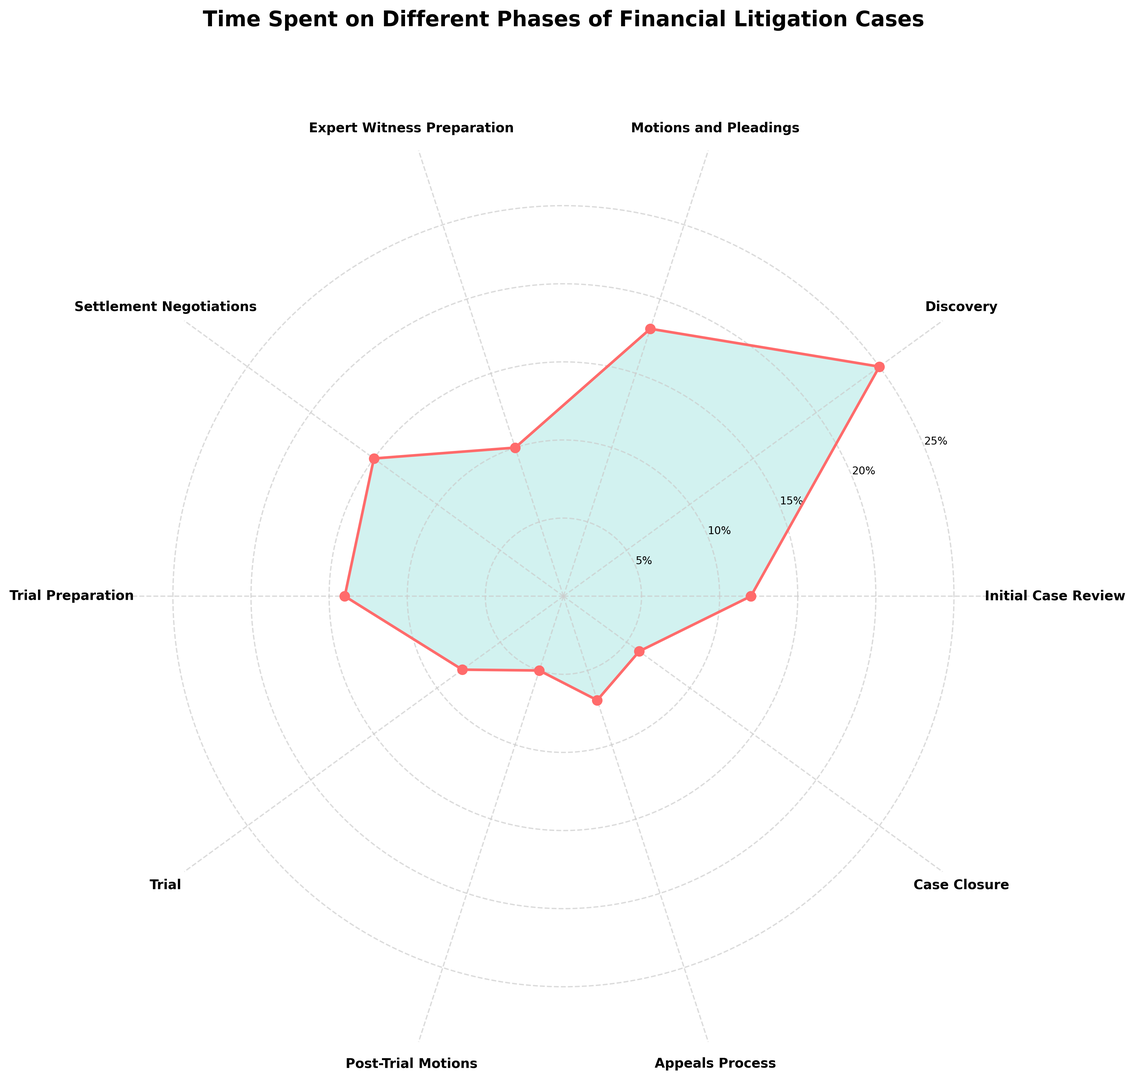Which phase takes the most time in financial litigation cases? The phase with the highest percentage is the Discovery phase at 25%. This can be seen at the topmost point of the rose chart.
Answer: Discovery Which phase takes less time than Trial but more time than Post-Trial Motions? Trial takes 8%, and Post-Trial Motions take 5%. The phase that lies between these two percentages is the Appeals Process at 7%.
Answer: Appeals Process How many phases take less than 10% of the total time? Identify phases with percentages below 10 on the chart: Trial (8%), Post-Trial Motions (5%), Appeals Process (7%), and Case Closure (6%). Count these up.
Answer: 4 What is the average time spent across the phases that are under 15%? Phases under 15% are: Initial Case Review (12%), Motions and Pleadings (18%), Expert Witness Preparation (10%), Trial Preparation (14%), Trial (8%), Post-Trial Motions (5%), Appeals Process (7%), and Case Closure (6%). Calculate their sum (12 + 18 + 10 + 14 + 8 + 5 + 7 + 6 = 80), and divide by the number of phases (8).
Answer: 10% Which phases combined sum up to roughly half of the total time? Discovery is 25%, and Motions and Pleadings is 18%. Adding these (25 + 18 = 43%) gives close to half. Including Settlement Negotiations (15%) makes the combined time 58%, which is over half. So only Discovery and Motions and Pleadings are almost half.
Answer: Discovery, Motions and Pleadings Which phase is represented by the smallest angle in the rose chart? The smallest percentage is Post-Trial Motions at 5%, which corresponds to the smallest angle on the chart.
Answer: Post-Trial Motions How much more time is spent on the Discovery phase compared to the Appeals Process? The Discovery phase takes 25%, and the Appeals Process takes 7%. The difference is (25% - 7% = 18%).
Answer: 18% Are settlement negotiations taking more or less time than Trial Preparation, and by how much? Settlement Negotiations is 15%, and Trial Preparation is 14%. The difference is (15% - 14% = 1%). Settlement Negotiations take more time.
Answer: More by 1% Which phases have a time percentage difference of more than 10% when compared side by side? Compare the percentages to find differences over 10%: Discovery (25%) and Initial Case Review (12%), Discovery and Expert Witness Preparation (10%), etc. Specifically, Discovery vs. Expert Witness Preparation (25% - 10% = 15%) and Discovery vs. Post-Trial Motions (25% - 5% = 20%), among others.
Answer: Discovery vs. Initial Case Review, Discovery vs. Expert Witness Preparation, Discovery vs. Post-Trial Motions What phases use up equal or less than 12% of the total time? Identify phases with 12% or less: Initial Case Review (12%), Expert Witness Preparation (10%), Trial (8%), Post-Trial Motions (5%), Appeals Process (7%), Case Closure (6%).
Answer: Initial Case Review, Expert Witness Preparation, Trial, Post-Trial Motions, Appeals Process, Case Closure 